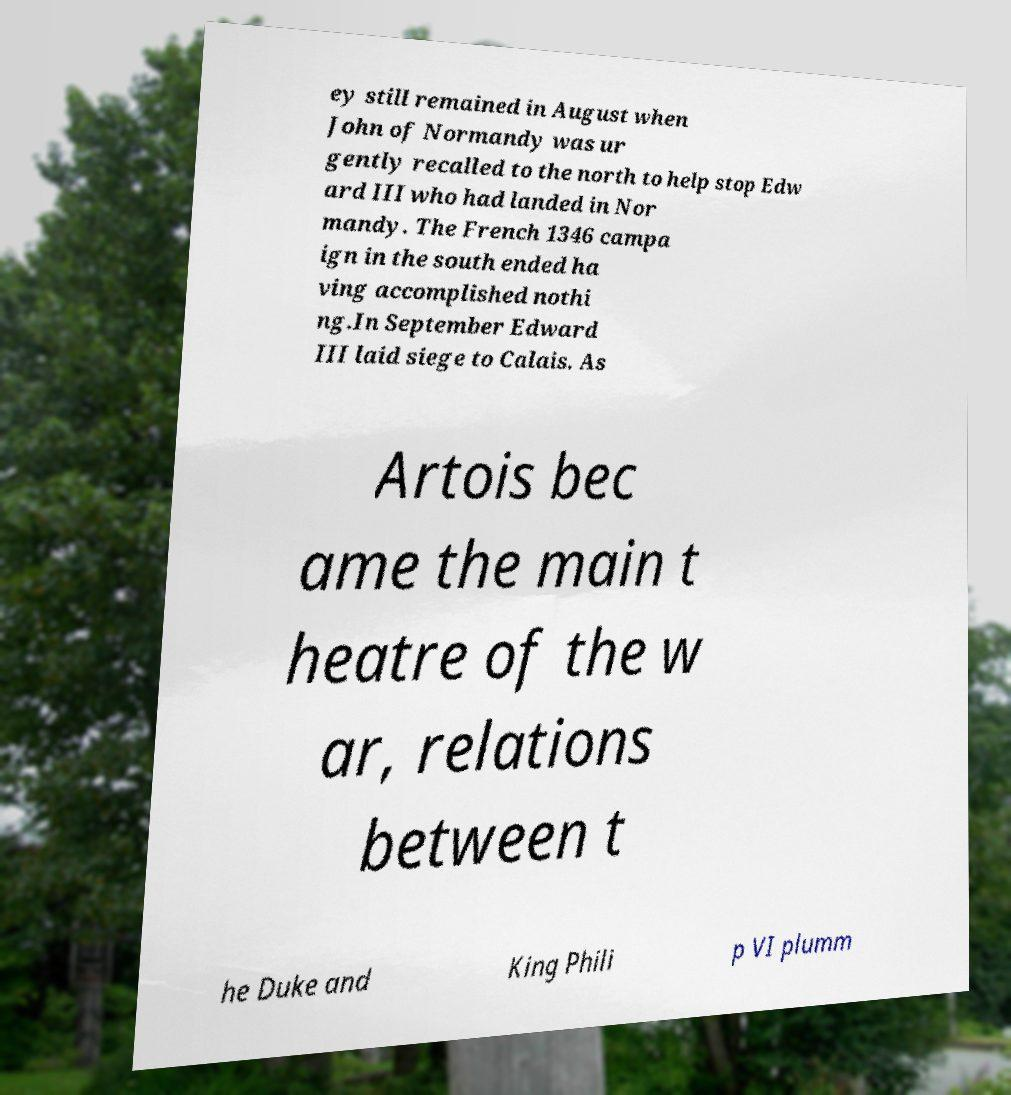Can you accurately transcribe the text from the provided image for me? ey still remained in August when John of Normandy was ur gently recalled to the north to help stop Edw ard III who had landed in Nor mandy. The French 1346 campa ign in the south ended ha ving accomplished nothi ng.In September Edward III laid siege to Calais. As Artois bec ame the main t heatre of the w ar, relations between t he Duke and King Phili p VI plumm 